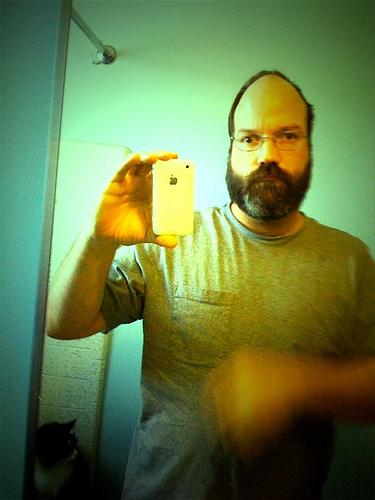Where is the man looking?
Concise answer only. Mirror. How many phones the man are  holding?
Short answer required. 1. Which hand is the man holding the object in?
Answer briefly. Right. Does this man look angry or happy?
Concise answer only. Angry. What color is the man's shirt?
Keep it brief. Gray. Is the picture of the man distorted?
Short answer required. Yes. 